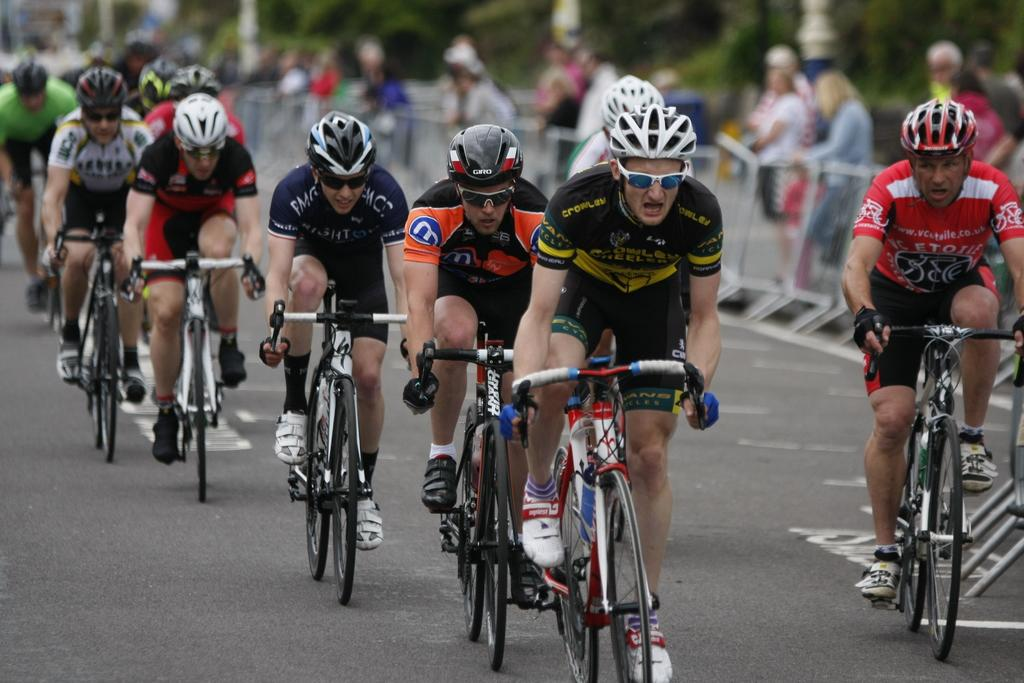What activity are the people in the image engaged in? The people in the image are riding bicycles. Where are the people riding their bicycles? They are riding on a road. What can be seen in the background of the image? There are people standing, barricades, and trees in the background of the image. What type of trail is being offered to the babies in the image? There are no babies or trails present in the image. 